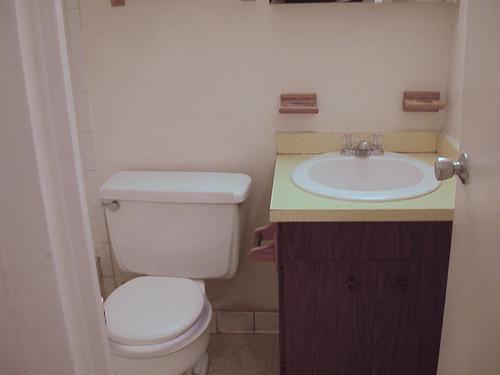How many sinks are there?
Give a very brief answer. 1. 